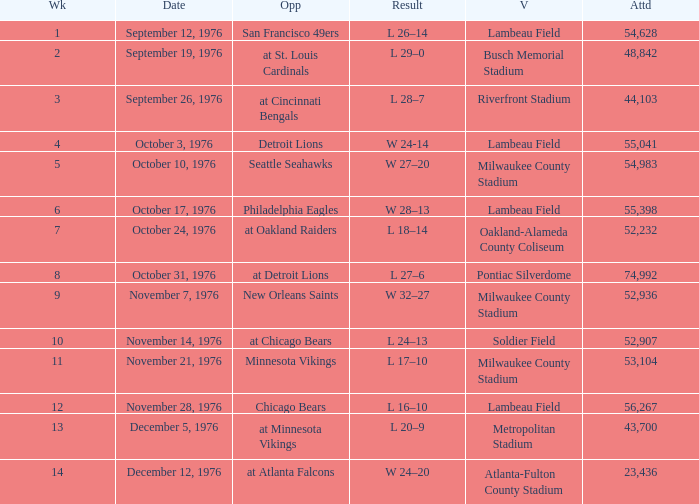What is the lowest week number where they played against the Detroit Lions? 4.0. 